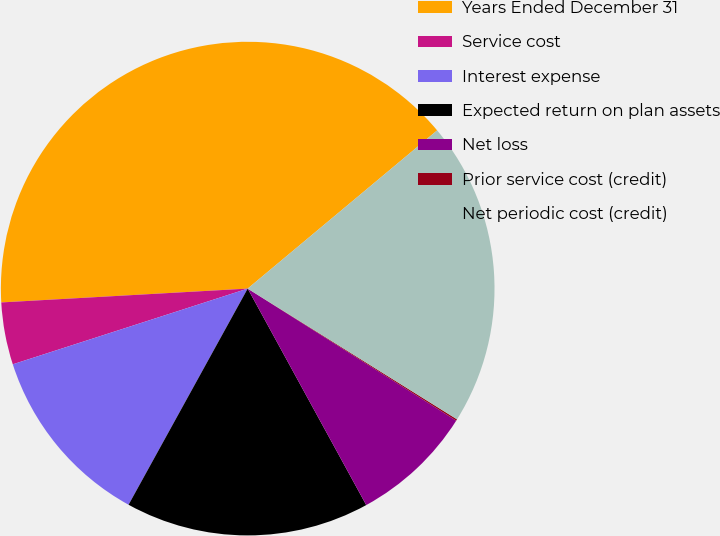Convert chart. <chart><loc_0><loc_0><loc_500><loc_500><pie_chart><fcel>Years Ended December 31<fcel>Service cost<fcel>Interest expense<fcel>Expected return on plan assets<fcel>Net loss<fcel>Prior service cost (credit)<fcel>Net periodic cost (credit)<nl><fcel>39.82%<fcel>4.07%<fcel>12.02%<fcel>15.99%<fcel>8.04%<fcel>0.1%<fcel>19.96%<nl></chart> 